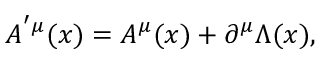Convert formula to latex. <formula><loc_0><loc_0><loc_500><loc_500>A ^ { ^ { \prime } \mu } ( x ) = A ^ { \mu } ( x ) + \partial ^ { \mu } \Lambda ( x ) ,</formula> 